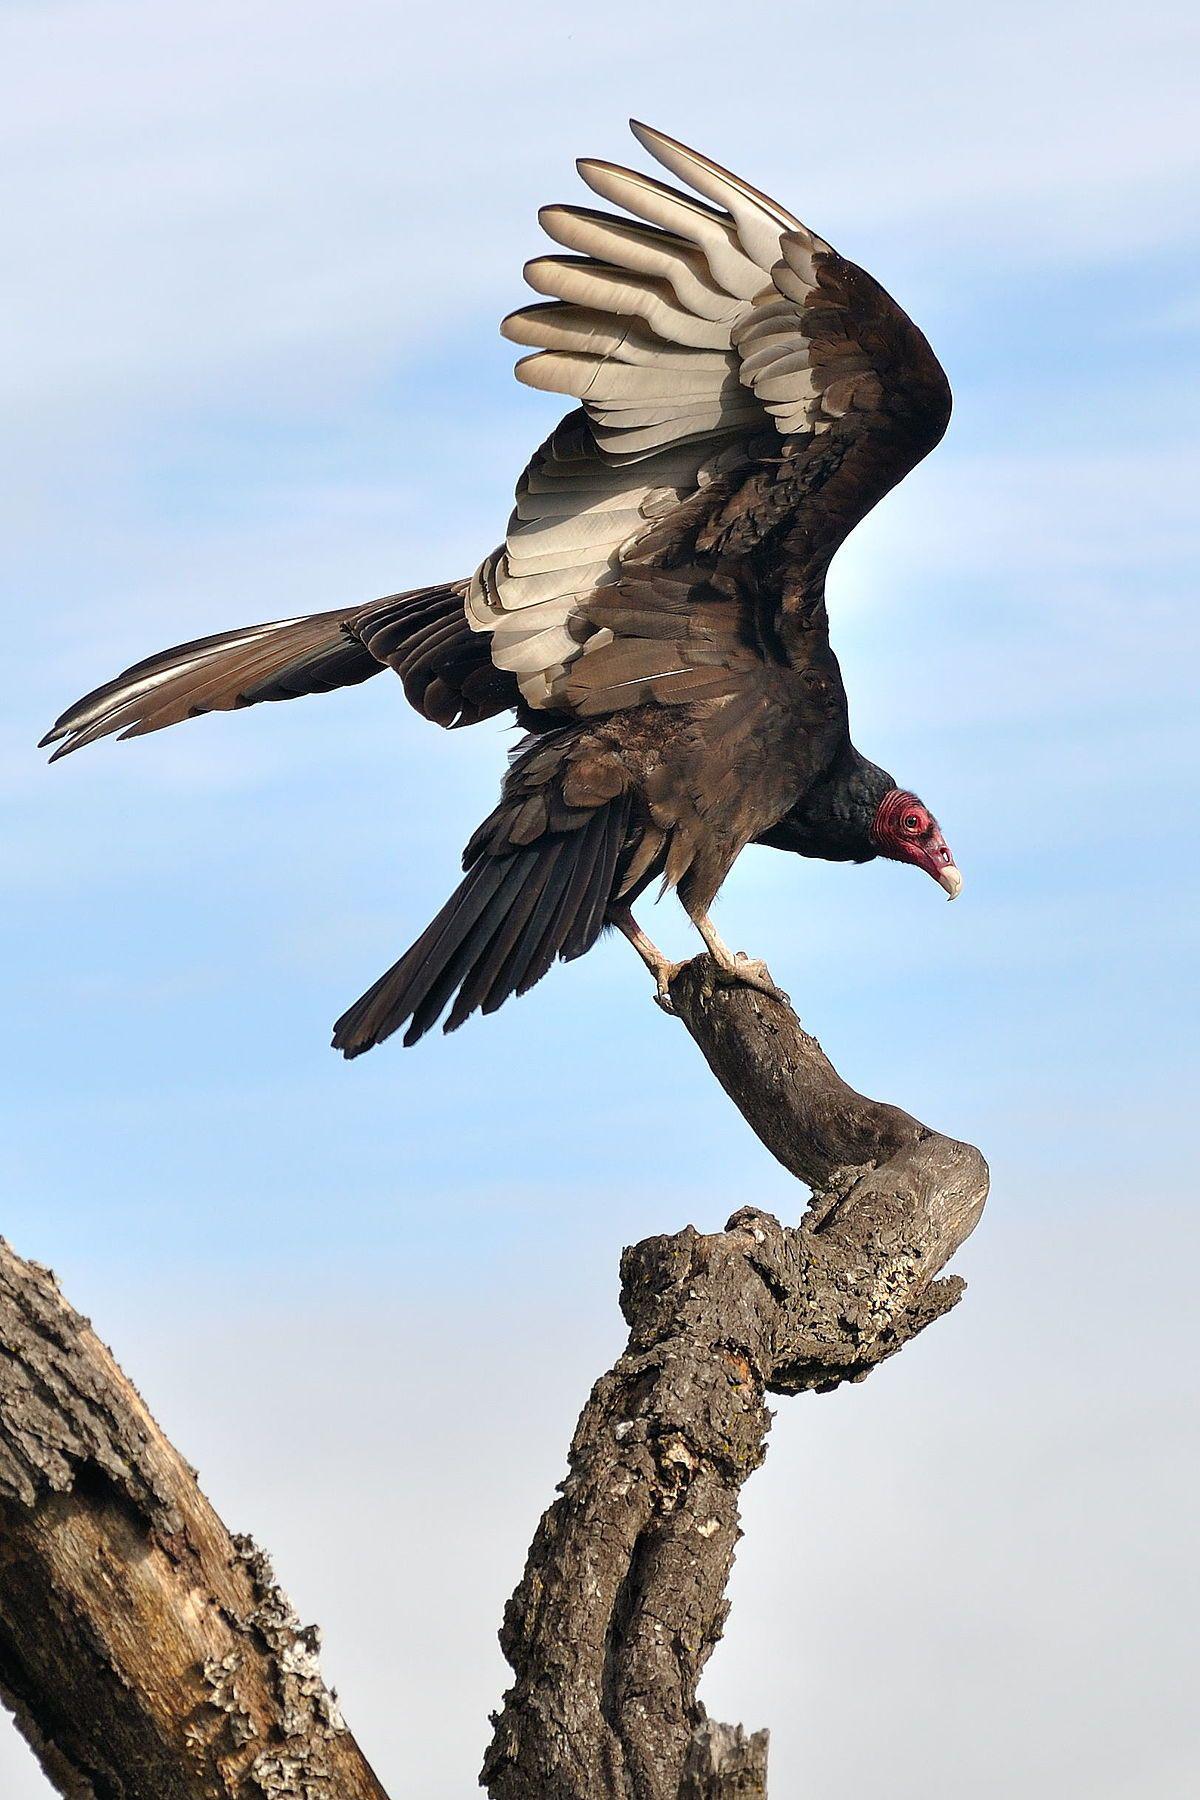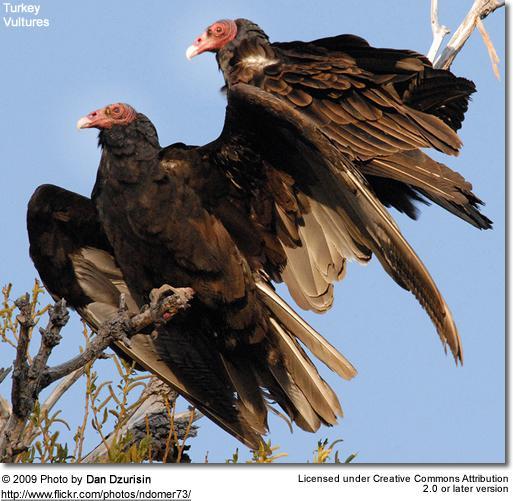The first image is the image on the left, the second image is the image on the right. Analyze the images presented: Is the assertion "The left and right image contains a total of two vultures facing different directions." valid? Answer yes or no. No. 